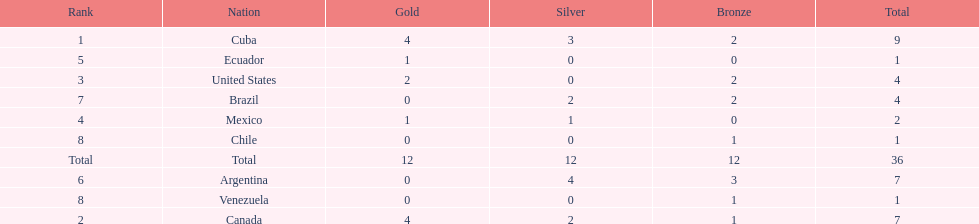What were the amounts of bronze medals won by the countries? 2, 1, 2, 0, 0, 3, 2, 1, 1. Which is the highest? 3. Which nation had this amount? Argentina. 